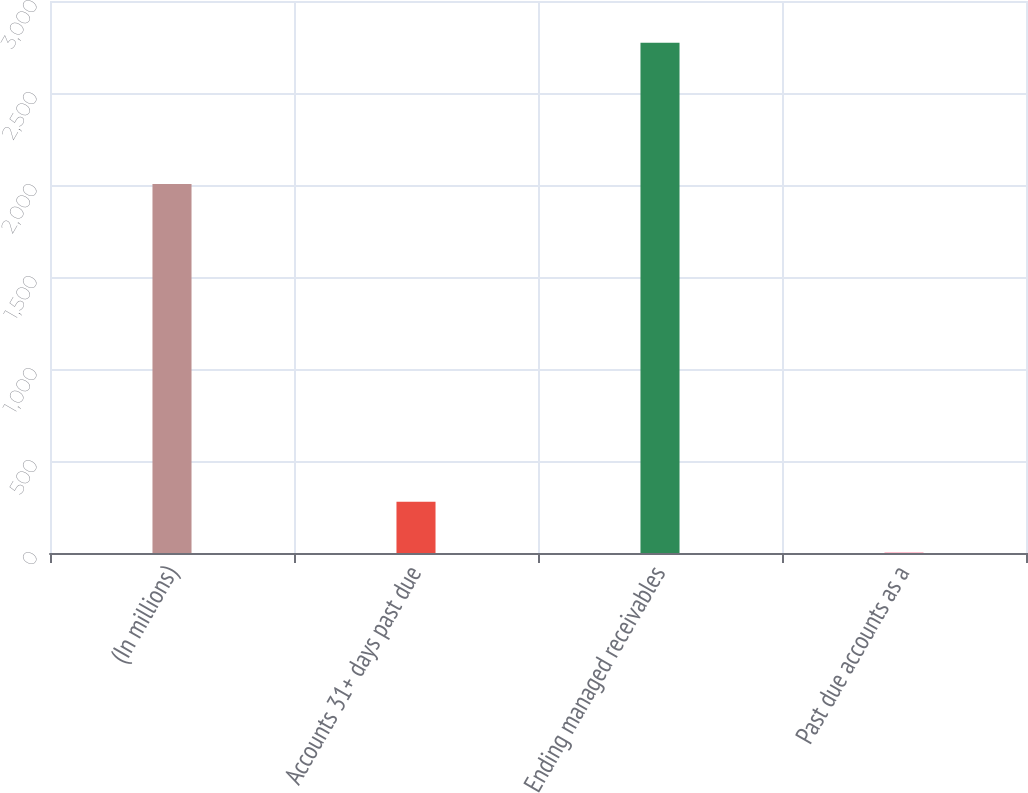Convert chart to OTSL. <chart><loc_0><loc_0><loc_500><loc_500><bar_chart><fcel>(In millions)<fcel>Accounts 31+ days past due<fcel>Ending managed receivables<fcel>Past due accounts as a<nl><fcel>2006<fcel>278.47<fcel>2772.5<fcel>1.35<nl></chart> 